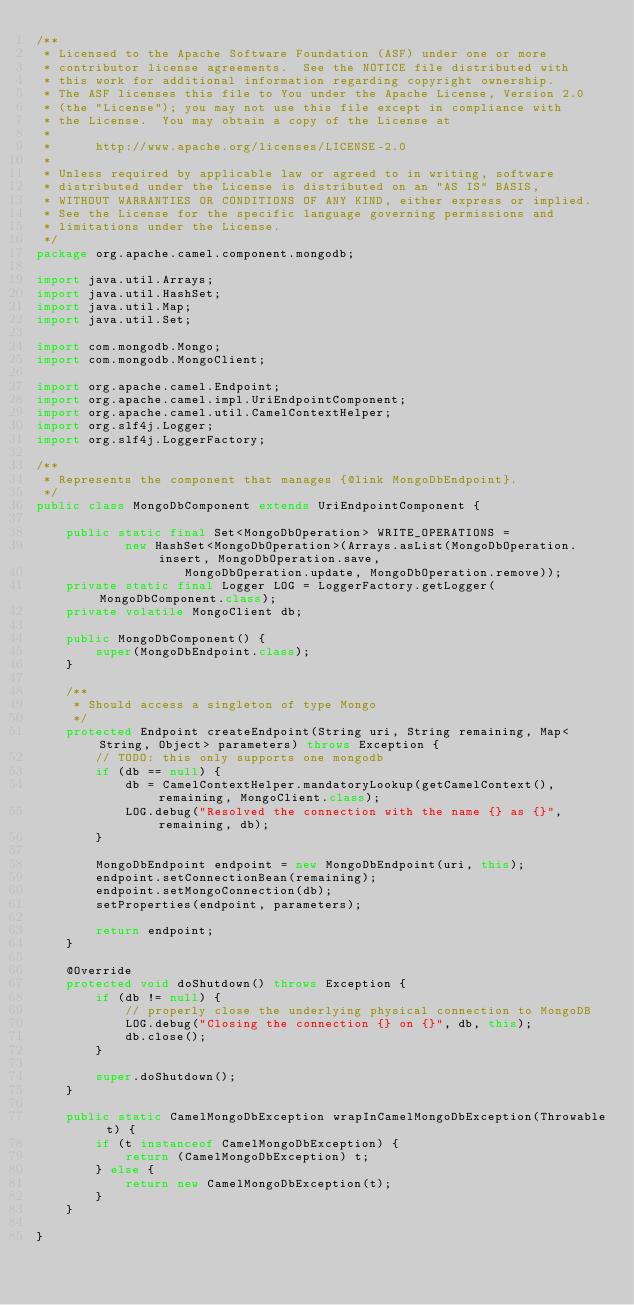<code> <loc_0><loc_0><loc_500><loc_500><_Java_>/**
 * Licensed to the Apache Software Foundation (ASF) under one or more
 * contributor license agreements.  See the NOTICE file distributed with
 * this work for additional information regarding copyright ownership.
 * The ASF licenses this file to You under the Apache License, Version 2.0
 * (the "License"); you may not use this file except in compliance with
 * the License.  You may obtain a copy of the License at
 *
 *      http://www.apache.org/licenses/LICENSE-2.0
 *
 * Unless required by applicable law or agreed to in writing, software
 * distributed under the License is distributed on an "AS IS" BASIS,
 * WITHOUT WARRANTIES OR CONDITIONS OF ANY KIND, either express or implied.
 * See the License for the specific language governing permissions and
 * limitations under the License.
 */
package org.apache.camel.component.mongodb;

import java.util.Arrays;
import java.util.HashSet;
import java.util.Map;
import java.util.Set;

import com.mongodb.Mongo;
import com.mongodb.MongoClient;

import org.apache.camel.Endpoint;
import org.apache.camel.impl.UriEndpointComponent;
import org.apache.camel.util.CamelContextHelper;
import org.slf4j.Logger;
import org.slf4j.LoggerFactory;

/**
 * Represents the component that manages {@link MongoDbEndpoint}.
 */
public class MongoDbComponent extends UriEndpointComponent {
    
    public static final Set<MongoDbOperation> WRITE_OPERATIONS = 
            new HashSet<MongoDbOperation>(Arrays.asList(MongoDbOperation.insert, MongoDbOperation.save, 
                    MongoDbOperation.update, MongoDbOperation.remove));
    private static final Logger LOG = LoggerFactory.getLogger(MongoDbComponent.class);
    private volatile MongoClient db;

    public MongoDbComponent() {
        super(MongoDbEndpoint.class);
    }

    /**
     * Should access a singleton of type Mongo
     */
    protected Endpoint createEndpoint(String uri, String remaining, Map<String, Object> parameters) throws Exception {
        // TODO: this only supports one mongodb
        if (db == null) {
            db = CamelContextHelper.mandatoryLookup(getCamelContext(), remaining, MongoClient.class);
            LOG.debug("Resolved the connection with the name {} as {}", remaining, db);
        }

        MongoDbEndpoint endpoint = new MongoDbEndpoint(uri, this);
        endpoint.setConnectionBean(remaining);
        endpoint.setMongoConnection(db);
        setProperties(endpoint, parameters);
        
        return endpoint;
    }

    @Override
    protected void doShutdown() throws Exception {
        if (db != null) {
            // properly close the underlying physical connection to MongoDB
            LOG.debug("Closing the connection {} on {}", db, this);
            db.close();
        }

        super.doShutdown();
    }

    public static CamelMongoDbException wrapInCamelMongoDbException(Throwable t) {
        if (t instanceof CamelMongoDbException) {
            return (CamelMongoDbException) t;
        } else {
            return new CamelMongoDbException(t);
        }
    }

}
</code> 